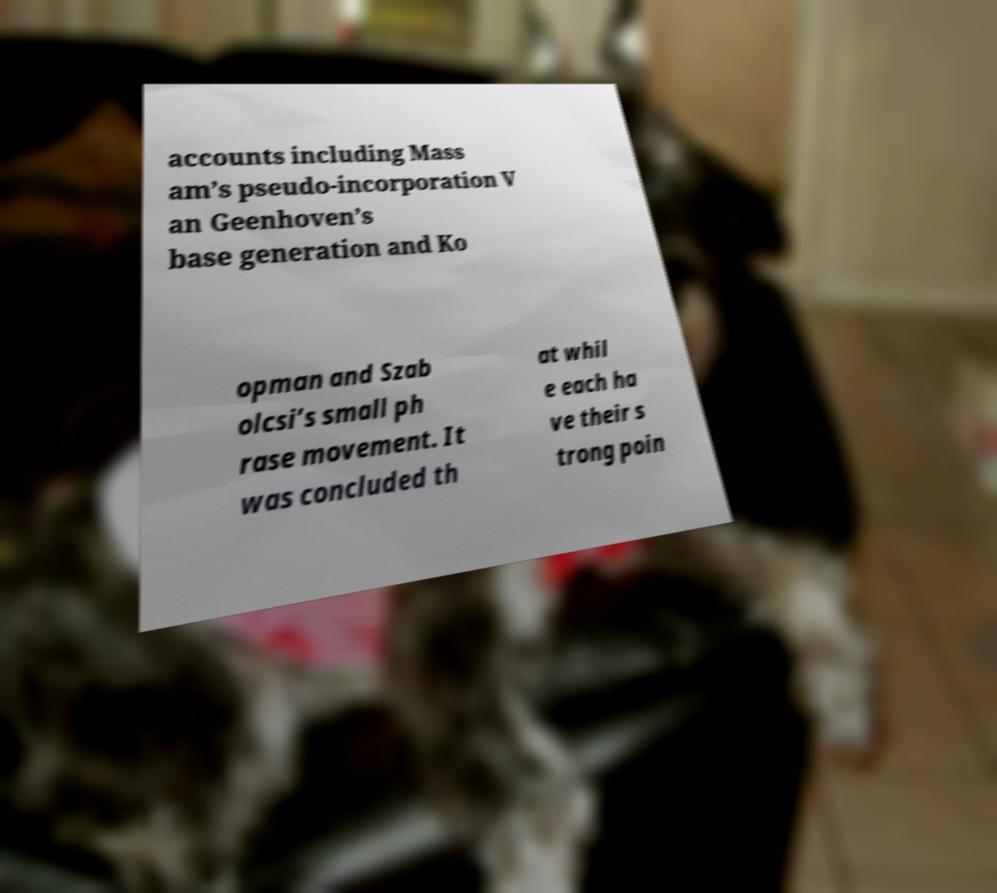For documentation purposes, I need the text within this image transcribed. Could you provide that? accounts including Mass am’s pseudo-incorporation V an Geenhoven’s base generation and Ko opman and Szab olcsi’s small ph rase movement. It was concluded th at whil e each ha ve their s trong poin 